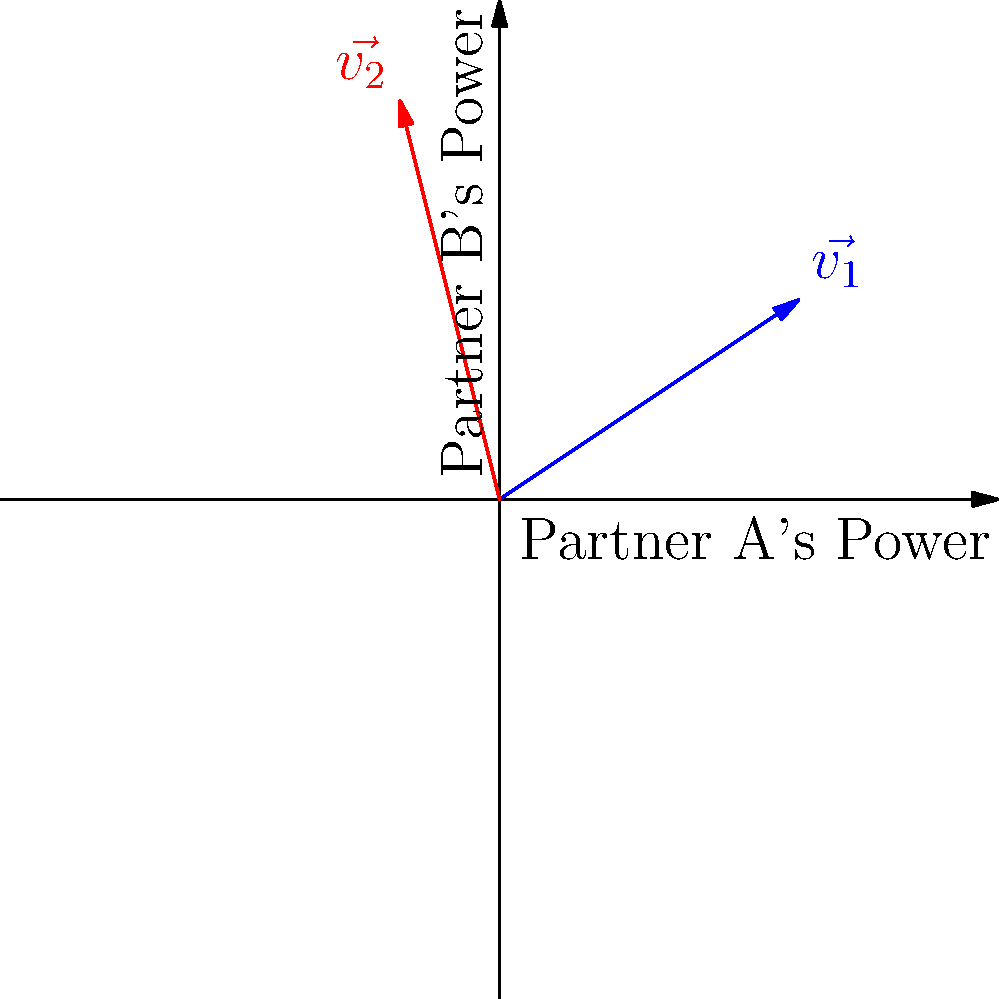In the context of relationship dynamics, two vectors $\vec{v_1}$ and $\vec{v_2}$ represent the power balance between partners A and B, respectively. $\vec{v_1} = (3,2)$ and $\vec{v_2} = (-1,4)$. Calculate the dot product of these vectors and interpret its meaning for the relationship. To solve this problem, we'll follow these steps:

1) The dot product of two vectors $\vec{a} = (a_1, a_2)$ and $\vec{b} = (b_1, b_2)$ is defined as:

   $\vec{a} \cdot \vec{b} = a_1b_1 + a_2b_2$

2) For our vectors:
   $\vec{v_1} = (3,2)$ and $\vec{v_2} = (-1,4)$

3) Calculating the dot product:
   $\vec{v_1} \cdot \vec{v_2} = (3)(-1) + (2)(4)$
                               $= -3 + 8$
                               $= 5$

4) Interpretation:
   - A positive dot product (5) indicates that the vectors are generally pointing in the same direction, suggesting some alignment in the partners' power dynamics.
   - However, the magnitude is relatively small (considering the lengths of the vectors), indicating only a moderate level of alignment.
   - The x-components have opposite signs, suggesting some opposition in one aspect of the relationship.
   - The positive result is mainly due to the y-components both being positive, indicating agreement in another aspect.

5) In relationship terms:
   - There's some overall alignment in how the partners exert power.
   - They may have conflicting approaches in one area (represented by the x-axis) but find agreement in another (y-axis).
   - The relationship shows a mix of cooperation and potential conflict in power dynamics.
Answer: 5; moderate alignment with mixed cooperation and conflict in power dynamics 